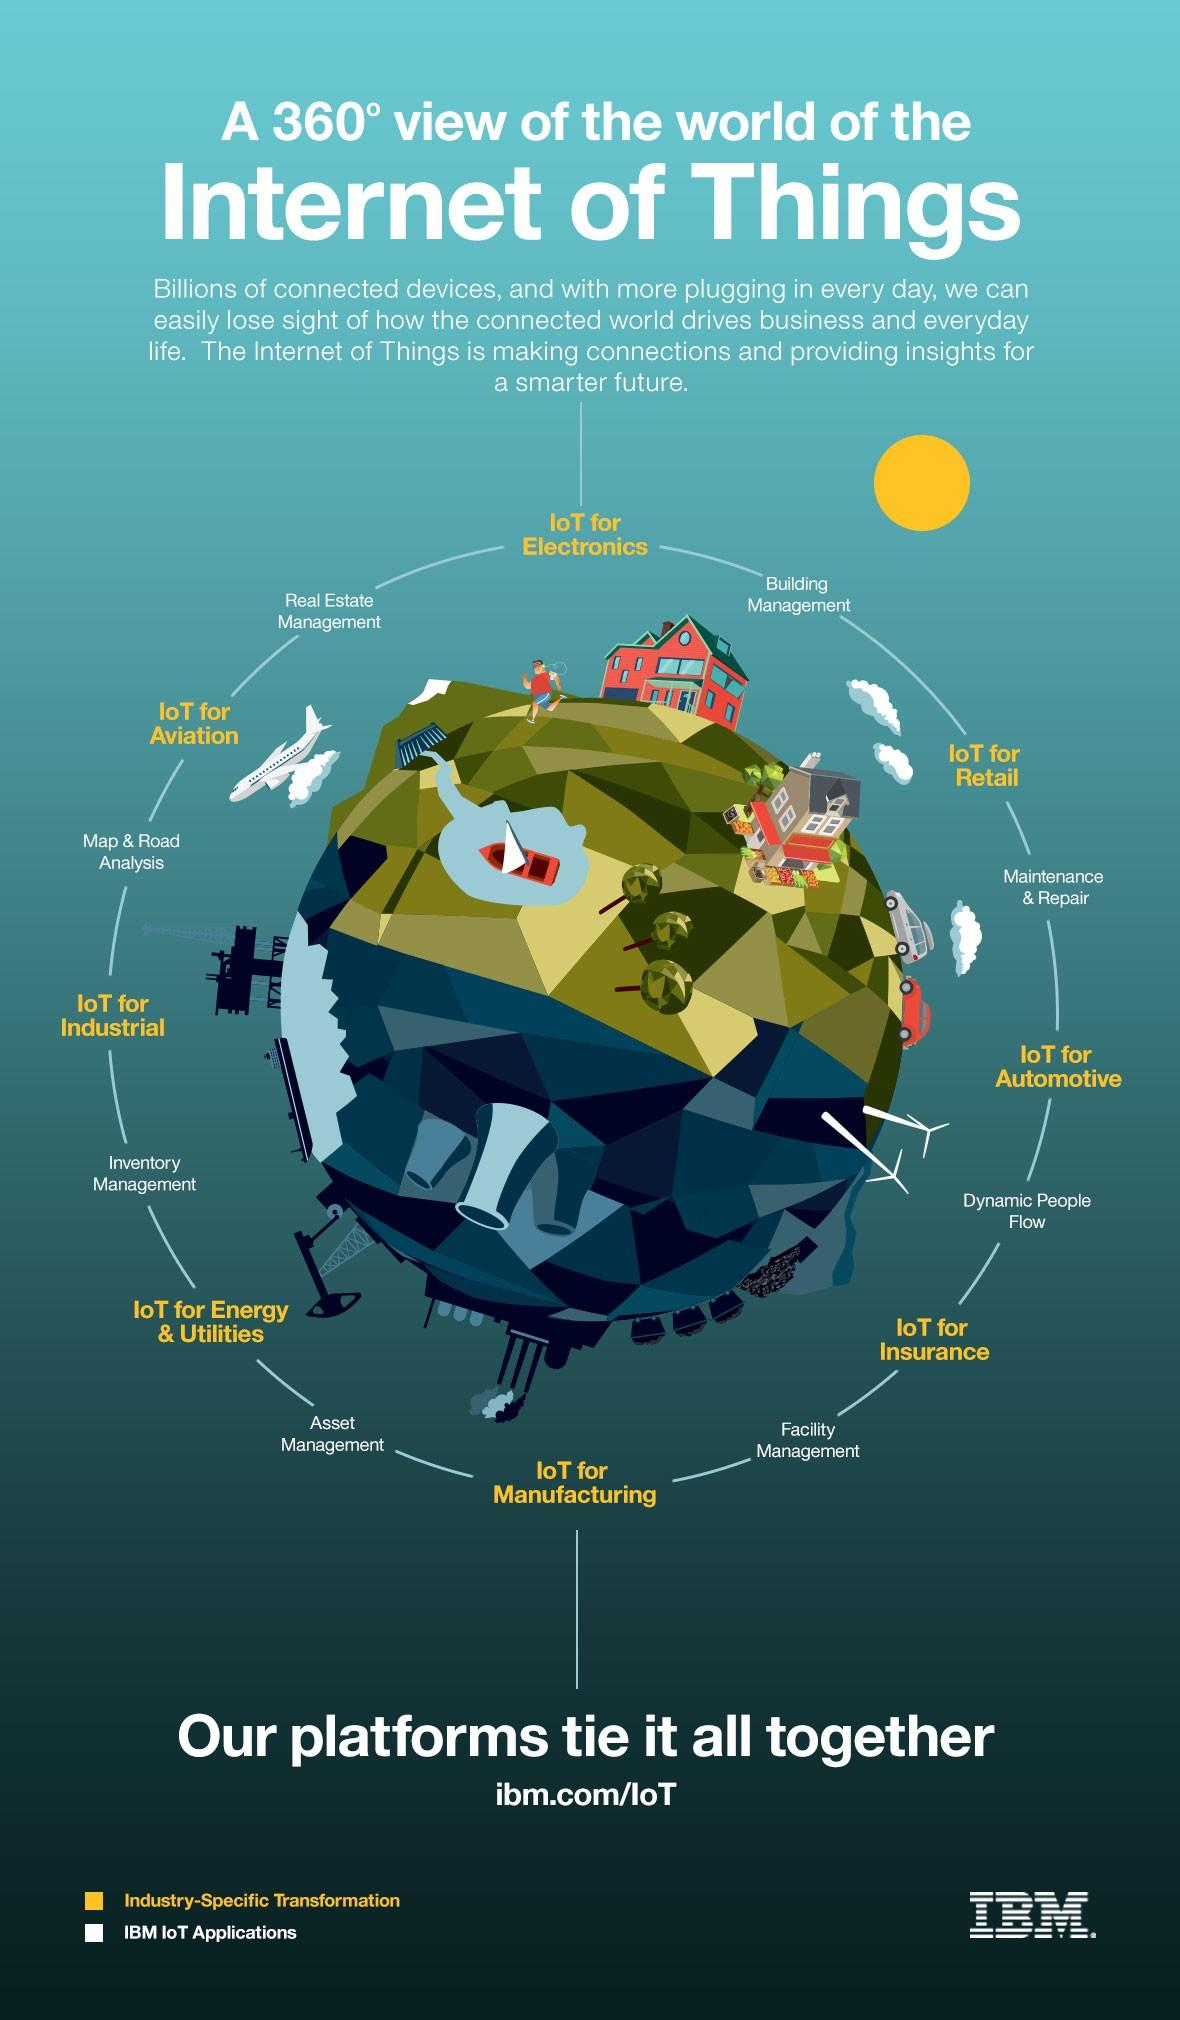Specify some key components in this picture. The Internet of Things has 8 branches or connections. 